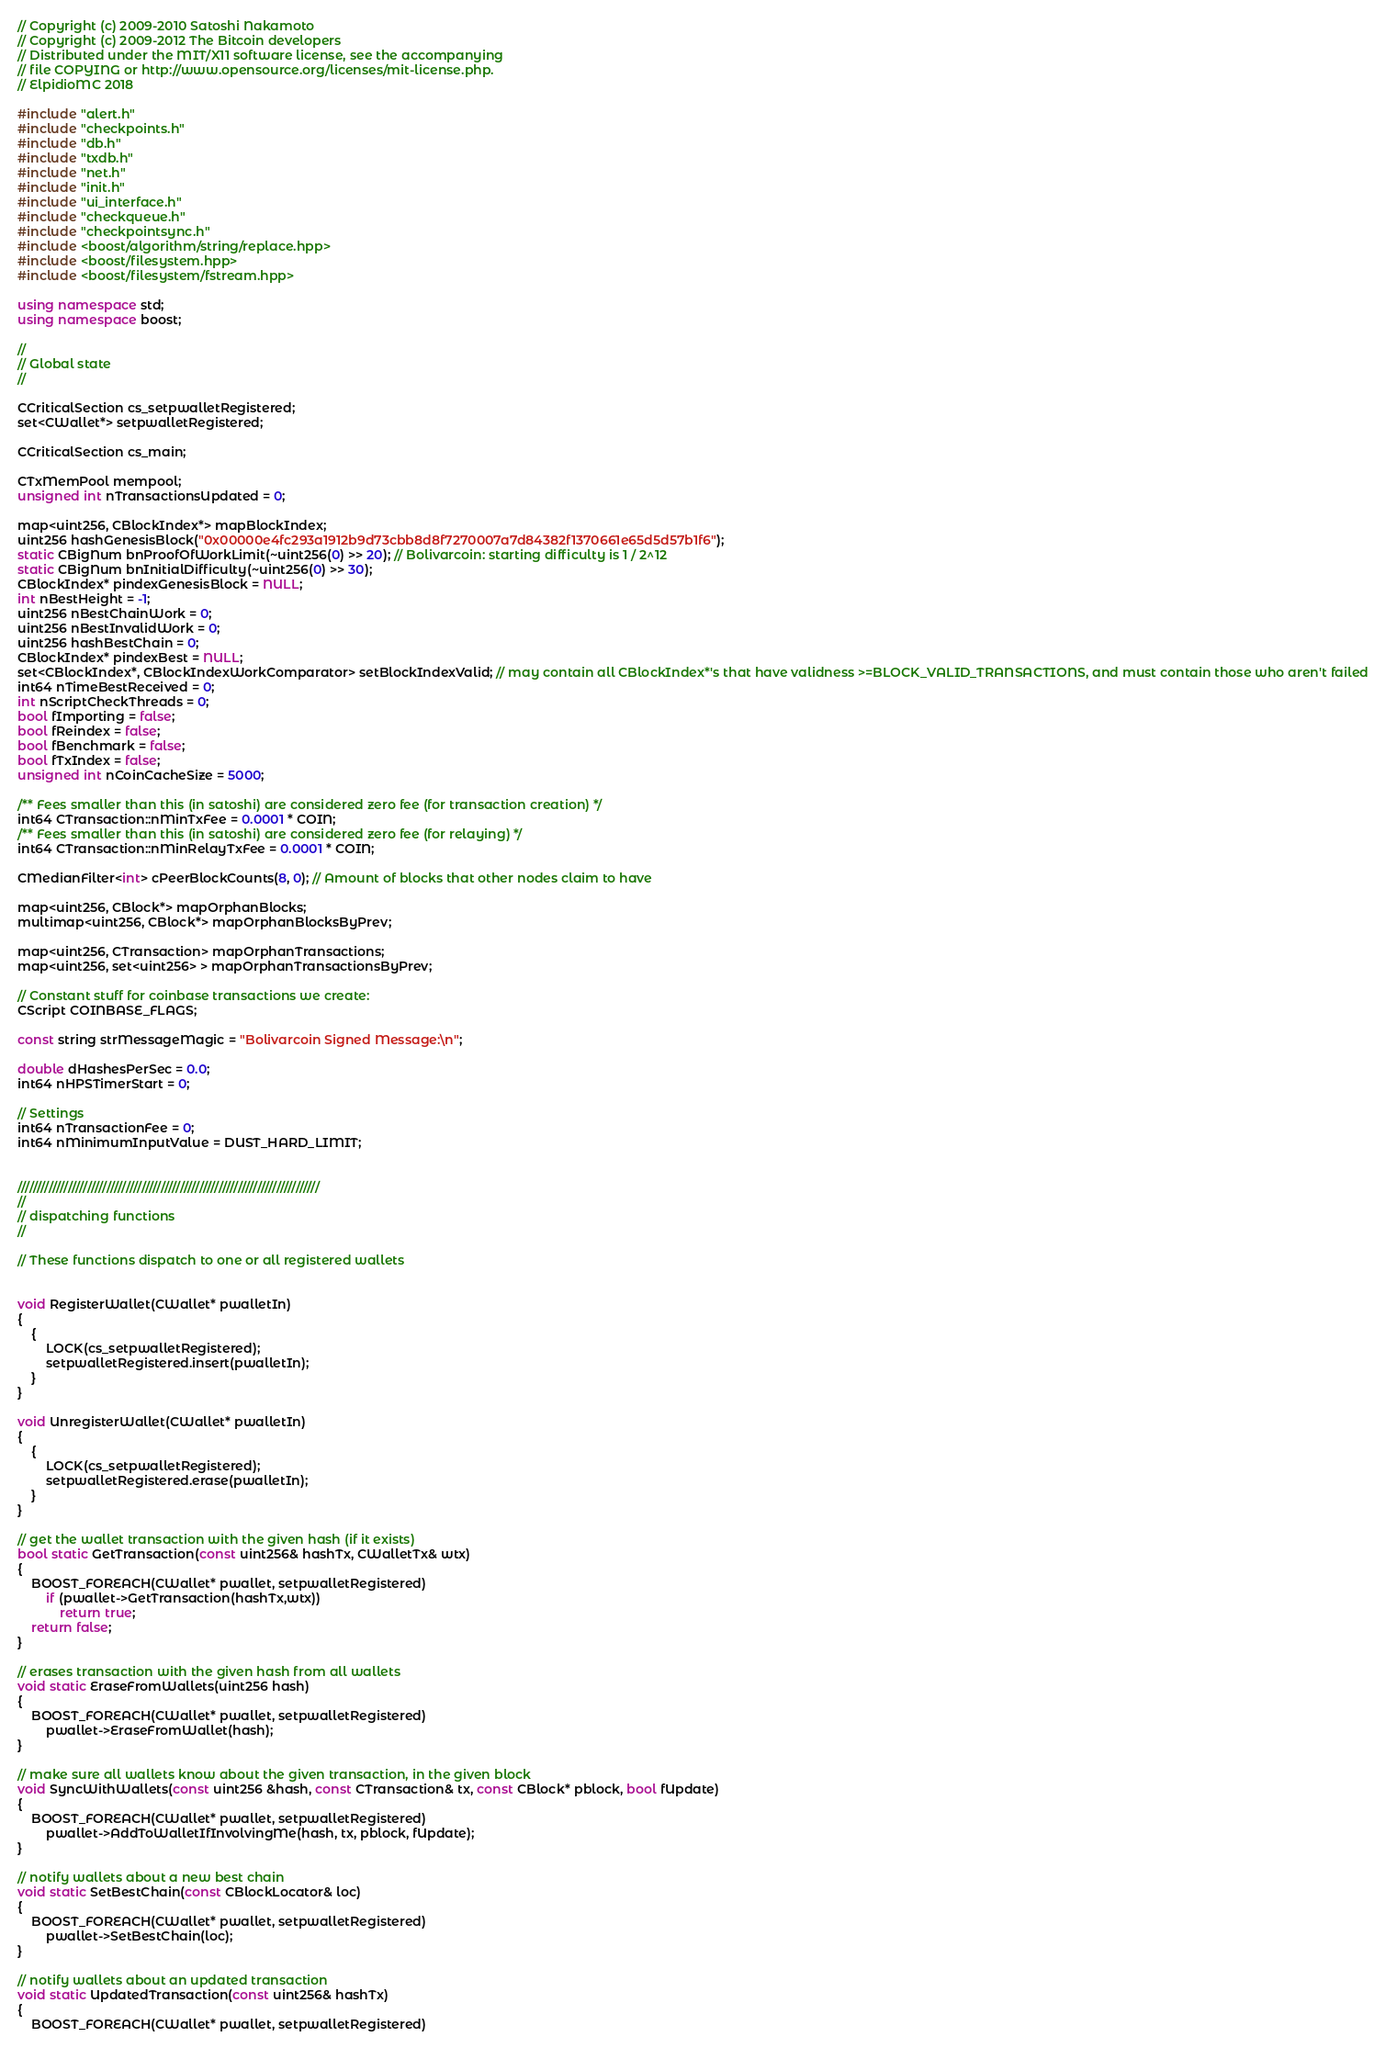Convert code to text. <code><loc_0><loc_0><loc_500><loc_500><_C++_>// Copyright (c) 2009-2010 Satoshi Nakamoto
// Copyright (c) 2009-2012 The Bitcoin developers
// Distributed under the MIT/X11 software license, see the accompanying
// file COPYING or http://www.opensource.org/licenses/mit-license.php.
// ElpidioMC 2018

#include "alert.h"
#include "checkpoints.h"
#include "db.h"
#include "txdb.h"
#include "net.h"
#include "init.h"
#include "ui_interface.h"
#include "checkqueue.h"
#include "checkpointsync.h"
#include <boost/algorithm/string/replace.hpp>
#include <boost/filesystem.hpp>
#include <boost/filesystem/fstream.hpp>

using namespace std;
using namespace boost;

//
// Global state
//

CCriticalSection cs_setpwalletRegistered;
set<CWallet*> setpwalletRegistered;

CCriticalSection cs_main;

CTxMemPool mempool;
unsigned int nTransactionsUpdated = 0;

map<uint256, CBlockIndex*> mapBlockIndex;
uint256 hashGenesisBlock("0x00000e4fc293a1912b9d73cbb8d8f7270007a7d84382f1370661e65d5d57b1f6");
static CBigNum bnProofOfWorkLimit(~uint256(0) >> 20); // Bolivarcoin: starting difficulty is 1 / 2^12
static CBigNum bnInitialDifficulty(~uint256(0) >> 30);
CBlockIndex* pindexGenesisBlock = NULL;
int nBestHeight = -1;
uint256 nBestChainWork = 0;
uint256 nBestInvalidWork = 0;
uint256 hashBestChain = 0;
CBlockIndex* pindexBest = NULL;
set<CBlockIndex*, CBlockIndexWorkComparator> setBlockIndexValid; // may contain all CBlockIndex*'s that have validness >=BLOCK_VALID_TRANSACTIONS, and must contain those who aren't failed
int64 nTimeBestReceived = 0;
int nScriptCheckThreads = 0;
bool fImporting = false;
bool fReindex = false;
bool fBenchmark = false;
bool fTxIndex = false;
unsigned int nCoinCacheSize = 5000;

/** Fees smaller than this (in satoshi) are considered zero fee (for transaction creation) */
int64 CTransaction::nMinTxFee = 0.0001 * COIN;
/** Fees smaller than this (in satoshi) are considered zero fee (for relaying) */
int64 CTransaction::nMinRelayTxFee = 0.0001 * COIN;

CMedianFilter<int> cPeerBlockCounts(8, 0); // Amount of blocks that other nodes claim to have

map<uint256, CBlock*> mapOrphanBlocks;
multimap<uint256, CBlock*> mapOrphanBlocksByPrev;

map<uint256, CTransaction> mapOrphanTransactions;
map<uint256, set<uint256> > mapOrphanTransactionsByPrev;

// Constant stuff for coinbase transactions we create:
CScript COINBASE_FLAGS;

const string strMessageMagic = "Bolivarcoin Signed Message:\n";

double dHashesPerSec = 0.0;
int64 nHPSTimerStart = 0;

// Settings
int64 nTransactionFee = 0;
int64 nMinimumInputValue = DUST_HARD_LIMIT;


//////////////////////////////////////////////////////////////////////////////
//
// dispatching functions
//

// These functions dispatch to one or all registered wallets


void RegisterWallet(CWallet* pwalletIn)
{
    {
        LOCK(cs_setpwalletRegistered);
        setpwalletRegistered.insert(pwalletIn);
    }
}

void UnregisterWallet(CWallet* pwalletIn)
{
    {
        LOCK(cs_setpwalletRegistered);
        setpwalletRegistered.erase(pwalletIn);
    }
}

// get the wallet transaction with the given hash (if it exists)
bool static GetTransaction(const uint256& hashTx, CWalletTx& wtx)
{
    BOOST_FOREACH(CWallet* pwallet, setpwalletRegistered)
        if (pwallet->GetTransaction(hashTx,wtx))
            return true;
    return false;
}

// erases transaction with the given hash from all wallets
void static EraseFromWallets(uint256 hash)
{
    BOOST_FOREACH(CWallet* pwallet, setpwalletRegistered)
        pwallet->EraseFromWallet(hash);
}

// make sure all wallets know about the given transaction, in the given block
void SyncWithWallets(const uint256 &hash, const CTransaction& tx, const CBlock* pblock, bool fUpdate)
{
    BOOST_FOREACH(CWallet* pwallet, setpwalletRegistered)
        pwallet->AddToWalletIfInvolvingMe(hash, tx, pblock, fUpdate);
}

// notify wallets about a new best chain
void static SetBestChain(const CBlockLocator& loc)
{
    BOOST_FOREACH(CWallet* pwallet, setpwalletRegistered)
        pwallet->SetBestChain(loc);
}

// notify wallets about an updated transaction
void static UpdatedTransaction(const uint256& hashTx)
{
    BOOST_FOREACH(CWallet* pwallet, setpwalletRegistered)</code> 